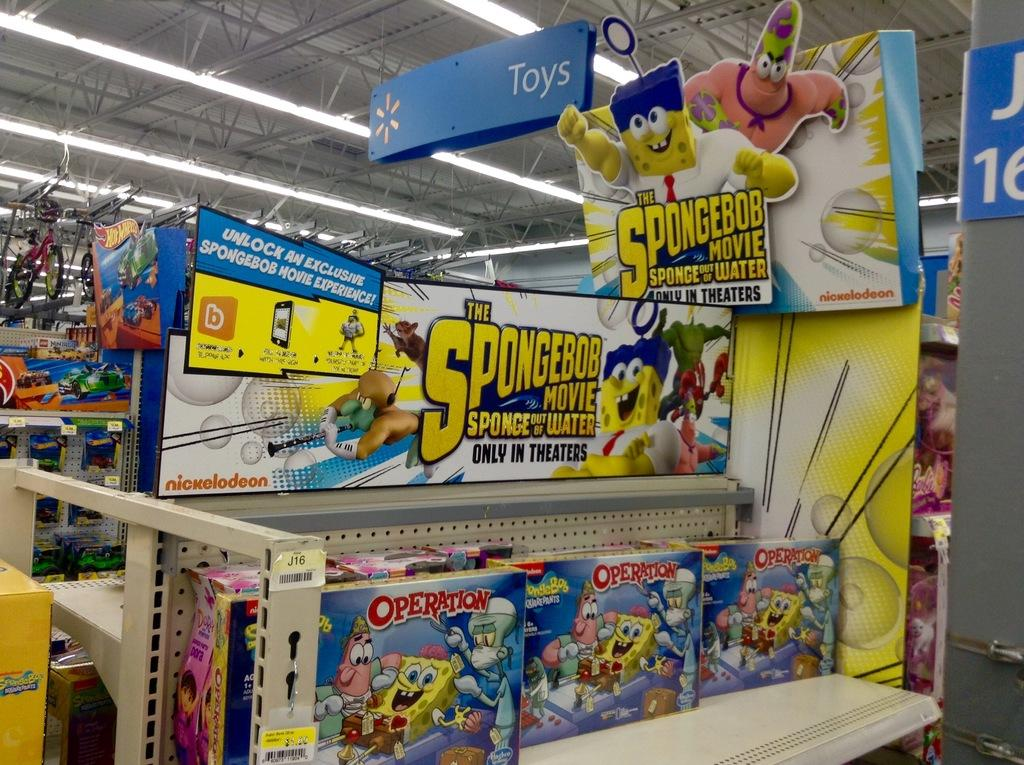<image>
Describe the image concisely. a sign for the spongebob squarepants movie in a store 